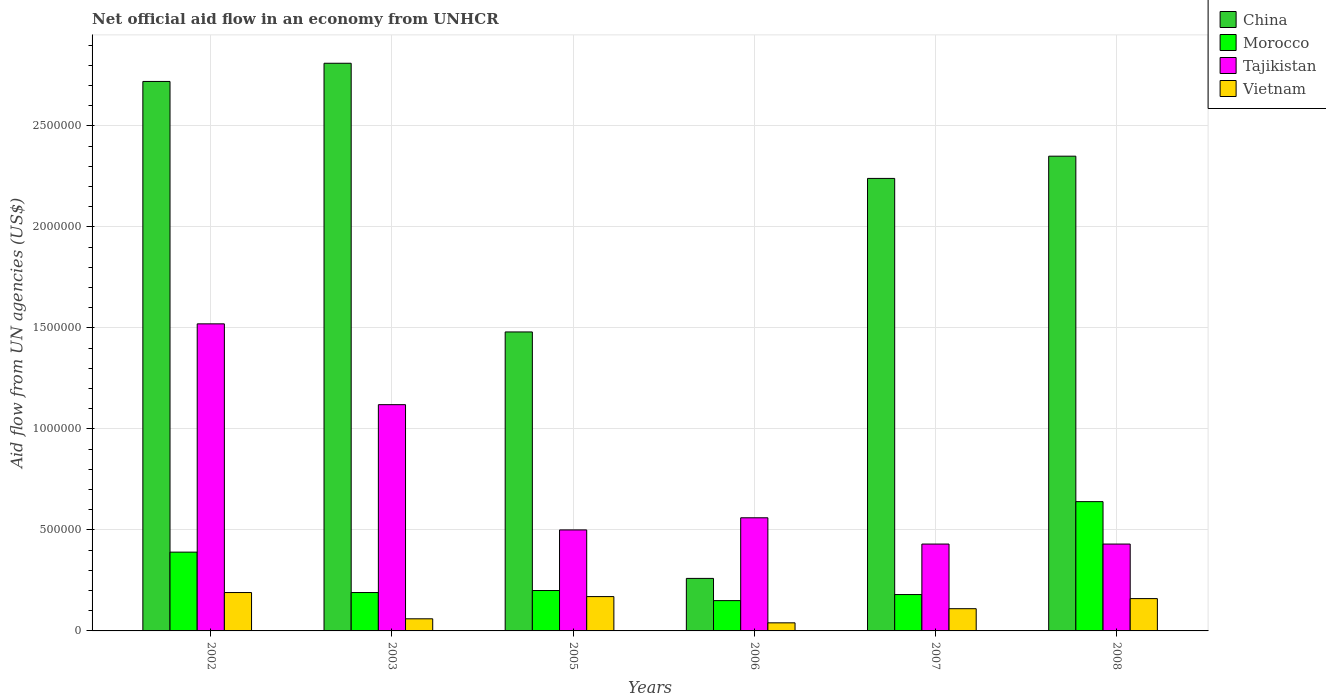How many different coloured bars are there?
Ensure brevity in your answer.  4. How many groups of bars are there?
Make the answer very short. 6. Are the number of bars per tick equal to the number of legend labels?
Ensure brevity in your answer.  Yes. Are the number of bars on each tick of the X-axis equal?
Your answer should be compact. Yes. In how many cases, is the number of bars for a given year not equal to the number of legend labels?
Offer a very short reply. 0. What is the net official aid flow in China in 2007?
Your response must be concise. 2.24e+06. Across all years, what is the maximum net official aid flow in Tajikistan?
Your response must be concise. 1.52e+06. Across all years, what is the minimum net official aid flow in Morocco?
Make the answer very short. 1.50e+05. In which year was the net official aid flow in Tajikistan maximum?
Offer a terse response. 2002. What is the total net official aid flow in China in the graph?
Provide a short and direct response. 1.19e+07. What is the difference between the net official aid flow in Tajikistan in 2003 and that in 2008?
Offer a very short reply. 6.90e+05. What is the difference between the net official aid flow in Tajikistan in 2003 and the net official aid flow in Morocco in 2005?
Give a very brief answer. 9.20e+05. What is the average net official aid flow in Vietnam per year?
Your answer should be very brief. 1.22e+05. In the year 2002, what is the difference between the net official aid flow in Morocco and net official aid flow in China?
Make the answer very short. -2.33e+06. What is the ratio of the net official aid flow in Morocco in 2005 to that in 2006?
Your answer should be very brief. 1.33. What is the difference between the highest and the second highest net official aid flow in Morocco?
Your answer should be very brief. 2.50e+05. What is the difference between the highest and the lowest net official aid flow in China?
Provide a succinct answer. 2.55e+06. In how many years, is the net official aid flow in Tajikistan greater than the average net official aid flow in Tajikistan taken over all years?
Ensure brevity in your answer.  2. What does the 4th bar from the left in 2007 represents?
Give a very brief answer. Vietnam. What does the 3rd bar from the right in 2003 represents?
Offer a terse response. Morocco. Is it the case that in every year, the sum of the net official aid flow in Vietnam and net official aid flow in Morocco is greater than the net official aid flow in China?
Offer a very short reply. No. How many years are there in the graph?
Your answer should be compact. 6. Are the values on the major ticks of Y-axis written in scientific E-notation?
Your answer should be very brief. No. Does the graph contain grids?
Provide a succinct answer. Yes. Where does the legend appear in the graph?
Offer a terse response. Top right. How are the legend labels stacked?
Offer a very short reply. Vertical. What is the title of the graph?
Offer a very short reply. Net official aid flow in an economy from UNHCR. What is the label or title of the X-axis?
Provide a succinct answer. Years. What is the label or title of the Y-axis?
Offer a terse response. Aid flow from UN agencies (US$). What is the Aid flow from UN agencies (US$) in China in 2002?
Offer a terse response. 2.72e+06. What is the Aid flow from UN agencies (US$) of Tajikistan in 2002?
Your response must be concise. 1.52e+06. What is the Aid flow from UN agencies (US$) in China in 2003?
Provide a short and direct response. 2.81e+06. What is the Aid flow from UN agencies (US$) of Morocco in 2003?
Make the answer very short. 1.90e+05. What is the Aid flow from UN agencies (US$) of Tajikistan in 2003?
Offer a very short reply. 1.12e+06. What is the Aid flow from UN agencies (US$) in China in 2005?
Your answer should be compact. 1.48e+06. What is the Aid flow from UN agencies (US$) in Morocco in 2005?
Offer a terse response. 2.00e+05. What is the Aid flow from UN agencies (US$) of Vietnam in 2005?
Offer a very short reply. 1.70e+05. What is the Aid flow from UN agencies (US$) in Tajikistan in 2006?
Offer a very short reply. 5.60e+05. What is the Aid flow from UN agencies (US$) of China in 2007?
Make the answer very short. 2.24e+06. What is the Aid flow from UN agencies (US$) of China in 2008?
Your answer should be compact. 2.35e+06. What is the Aid flow from UN agencies (US$) of Morocco in 2008?
Offer a very short reply. 6.40e+05. Across all years, what is the maximum Aid flow from UN agencies (US$) in China?
Give a very brief answer. 2.81e+06. Across all years, what is the maximum Aid flow from UN agencies (US$) in Morocco?
Keep it short and to the point. 6.40e+05. Across all years, what is the maximum Aid flow from UN agencies (US$) of Tajikistan?
Offer a terse response. 1.52e+06. Across all years, what is the minimum Aid flow from UN agencies (US$) in China?
Your answer should be very brief. 2.60e+05. Across all years, what is the minimum Aid flow from UN agencies (US$) in Morocco?
Offer a very short reply. 1.50e+05. Across all years, what is the minimum Aid flow from UN agencies (US$) of Vietnam?
Offer a terse response. 4.00e+04. What is the total Aid flow from UN agencies (US$) in China in the graph?
Your answer should be very brief. 1.19e+07. What is the total Aid flow from UN agencies (US$) in Morocco in the graph?
Provide a succinct answer. 1.75e+06. What is the total Aid flow from UN agencies (US$) of Tajikistan in the graph?
Keep it short and to the point. 4.56e+06. What is the total Aid flow from UN agencies (US$) in Vietnam in the graph?
Your answer should be very brief. 7.30e+05. What is the difference between the Aid flow from UN agencies (US$) in China in 2002 and that in 2003?
Provide a succinct answer. -9.00e+04. What is the difference between the Aid flow from UN agencies (US$) of Tajikistan in 2002 and that in 2003?
Provide a succinct answer. 4.00e+05. What is the difference between the Aid flow from UN agencies (US$) of China in 2002 and that in 2005?
Provide a succinct answer. 1.24e+06. What is the difference between the Aid flow from UN agencies (US$) of Morocco in 2002 and that in 2005?
Ensure brevity in your answer.  1.90e+05. What is the difference between the Aid flow from UN agencies (US$) in Tajikistan in 2002 and that in 2005?
Give a very brief answer. 1.02e+06. What is the difference between the Aid flow from UN agencies (US$) in Vietnam in 2002 and that in 2005?
Offer a very short reply. 2.00e+04. What is the difference between the Aid flow from UN agencies (US$) of China in 2002 and that in 2006?
Provide a short and direct response. 2.46e+06. What is the difference between the Aid flow from UN agencies (US$) of Tajikistan in 2002 and that in 2006?
Offer a very short reply. 9.60e+05. What is the difference between the Aid flow from UN agencies (US$) of China in 2002 and that in 2007?
Your answer should be very brief. 4.80e+05. What is the difference between the Aid flow from UN agencies (US$) of Tajikistan in 2002 and that in 2007?
Your answer should be very brief. 1.09e+06. What is the difference between the Aid flow from UN agencies (US$) in Vietnam in 2002 and that in 2007?
Offer a very short reply. 8.00e+04. What is the difference between the Aid flow from UN agencies (US$) of Morocco in 2002 and that in 2008?
Offer a terse response. -2.50e+05. What is the difference between the Aid flow from UN agencies (US$) in Tajikistan in 2002 and that in 2008?
Your response must be concise. 1.09e+06. What is the difference between the Aid flow from UN agencies (US$) of China in 2003 and that in 2005?
Keep it short and to the point. 1.33e+06. What is the difference between the Aid flow from UN agencies (US$) of Tajikistan in 2003 and that in 2005?
Offer a very short reply. 6.20e+05. What is the difference between the Aid flow from UN agencies (US$) of China in 2003 and that in 2006?
Offer a very short reply. 2.55e+06. What is the difference between the Aid flow from UN agencies (US$) of Tajikistan in 2003 and that in 2006?
Your response must be concise. 5.60e+05. What is the difference between the Aid flow from UN agencies (US$) in China in 2003 and that in 2007?
Ensure brevity in your answer.  5.70e+05. What is the difference between the Aid flow from UN agencies (US$) of Tajikistan in 2003 and that in 2007?
Provide a succinct answer. 6.90e+05. What is the difference between the Aid flow from UN agencies (US$) of Morocco in 2003 and that in 2008?
Your response must be concise. -4.50e+05. What is the difference between the Aid flow from UN agencies (US$) of Tajikistan in 2003 and that in 2008?
Offer a terse response. 6.90e+05. What is the difference between the Aid flow from UN agencies (US$) of China in 2005 and that in 2006?
Provide a succinct answer. 1.22e+06. What is the difference between the Aid flow from UN agencies (US$) of Morocco in 2005 and that in 2006?
Your answer should be compact. 5.00e+04. What is the difference between the Aid flow from UN agencies (US$) of China in 2005 and that in 2007?
Make the answer very short. -7.60e+05. What is the difference between the Aid flow from UN agencies (US$) in Morocco in 2005 and that in 2007?
Make the answer very short. 2.00e+04. What is the difference between the Aid flow from UN agencies (US$) of Vietnam in 2005 and that in 2007?
Your response must be concise. 6.00e+04. What is the difference between the Aid flow from UN agencies (US$) in China in 2005 and that in 2008?
Give a very brief answer. -8.70e+05. What is the difference between the Aid flow from UN agencies (US$) of Morocco in 2005 and that in 2008?
Give a very brief answer. -4.40e+05. What is the difference between the Aid flow from UN agencies (US$) in Tajikistan in 2005 and that in 2008?
Keep it short and to the point. 7.00e+04. What is the difference between the Aid flow from UN agencies (US$) in China in 2006 and that in 2007?
Give a very brief answer. -1.98e+06. What is the difference between the Aid flow from UN agencies (US$) in Morocco in 2006 and that in 2007?
Your response must be concise. -3.00e+04. What is the difference between the Aid flow from UN agencies (US$) in Tajikistan in 2006 and that in 2007?
Your answer should be compact. 1.30e+05. What is the difference between the Aid flow from UN agencies (US$) of China in 2006 and that in 2008?
Make the answer very short. -2.09e+06. What is the difference between the Aid flow from UN agencies (US$) in Morocco in 2006 and that in 2008?
Offer a very short reply. -4.90e+05. What is the difference between the Aid flow from UN agencies (US$) in Morocco in 2007 and that in 2008?
Offer a terse response. -4.60e+05. What is the difference between the Aid flow from UN agencies (US$) in Tajikistan in 2007 and that in 2008?
Keep it short and to the point. 0. What is the difference between the Aid flow from UN agencies (US$) in China in 2002 and the Aid flow from UN agencies (US$) in Morocco in 2003?
Give a very brief answer. 2.53e+06. What is the difference between the Aid flow from UN agencies (US$) of China in 2002 and the Aid flow from UN agencies (US$) of Tajikistan in 2003?
Give a very brief answer. 1.60e+06. What is the difference between the Aid flow from UN agencies (US$) in China in 2002 and the Aid flow from UN agencies (US$) in Vietnam in 2003?
Keep it short and to the point. 2.66e+06. What is the difference between the Aid flow from UN agencies (US$) of Morocco in 2002 and the Aid flow from UN agencies (US$) of Tajikistan in 2003?
Offer a terse response. -7.30e+05. What is the difference between the Aid flow from UN agencies (US$) in Morocco in 2002 and the Aid flow from UN agencies (US$) in Vietnam in 2003?
Provide a short and direct response. 3.30e+05. What is the difference between the Aid flow from UN agencies (US$) of Tajikistan in 2002 and the Aid flow from UN agencies (US$) of Vietnam in 2003?
Keep it short and to the point. 1.46e+06. What is the difference between the Aid flow from UN agencies (US$) in China in 2002 and the Aid flow from UN agencies (US$) in Morocco in 2005?
Make the answer very short. 2.52e+06. What is the difference between the Aid flow from UN agencies (US$) of China in 2002 and the Aid flow from UN agencies (US$) of Tajikistan in 2005?
Your answer should be compact. 2.22e+06. What is the difference between the Aid flow from UN agencies (US$) in China in 2002 and the Aid flow from UN agencies (US$) in Vietnam in 2005?
Provide a short and direct response. 2.55e+06. What is the difference between the Aid flow from UN agencies (US$) of Morocco in 2002 and the Aid flow from UN agencies (US$) of Tajikistan in 2005?
Your response must be concise. -1.10e+05. What is the difference between the Aid flow from UN agencies (US$) in Morocco in 2002 and the Aid flow from UN agencies (US$) in Vietnam in 2005?
Your answer should be compact. 2.20e+05. What is the difference between the Aid flow from UN agencies (US$) of Tajikistan in 2002 and the Aid flow from UN agencies (US$) of Vietnam in 2005?
Make the answer very short. 1.35e+06. What is the difference between the Aid flow from UN agencies (US$) of China in 2002 and the Aid flow from UN agencies (US$) of Morocco in 2006?
Provide a succinct answer. 2.57e+06. What is the difference between the Aid flow from UN agencies (US$) in China in 2002 and the Aid flow from UN agencies (US$) in Tajikistan in 2006?
Your response must be concise. 2.16e+06. What is the difference between the Aid flow from UN agencies (US$) of China in 2002 and the Aid flow from UN agencies (US$) of Vietnam in 2006?
Provide a succinct answer. 2.68e+06. What is the difference between the Aid flow from UN agencies (US$) in Morocco in 2002 and the Aid flow from UN agencies (US$) in Tajikistan in 2006?
Make the answer very short. -1.70e+05. What is the difference between the Aid flow from UN agencies (US$) in Tajikistan in 2002 and the Aid flow from UN agencies (US$) in Vietnam in 2006?
Provide a succinct answer. 1.48e+06. What is the difference between the Aid flow from UN agencies (US$) in China in 2002 and the Aid flow from UN agencies (US$) in Morocco in 2007?
Provide a succinct answer. 2.54e+06. What is the difference between the Aid flow from UN agencies (US$) of China in 2002 and the Aid flow from UN agencies (US$) of Tajikistan in 2007?
Your answer should be compact. 2.29e+06. What is the difference between the Aid flow from UN agencies (US$) of China in 2002 and the Aid flow from UN agencies (US$) of Vietnam in 2007?
Provide a succinct answer. 2.61e+06. What is the difference between the Aid flow from UN agencies (US$) in Morocco in 2002 and the Aid flow from UN agencies (US$) in Vietnam in 2007?
Make the answer very short. 2.80e+05. What is the difference between the Aid flow from UN agencies (US$) in Tajikistan in 2002 and the Aid flow from UN agencies (US$) in Vietnam in 2007?
Ensure brevity in your answer.  1.41e+06. What is the difference between the Aid flow from UN agencies (US$) in China in 2002 and the Aid flow from UN agencies (US$) in Morocco in 2008?
Your answer should be compact. 2.08e+06. What is the difference between the Aid flow from UN agencies (US$) in China in 2002 and the Aid flow from UN agencies (US$) in Tajikistan in 2008?
Provide a short and direct response. 2.29e+06. What is the difference between the Aid flow from UN agencies (US$) of China in 2002 and the Aid flow from UN agencies (US$) of Vietnam in 2008?
Give a very brief answer. 2.56e+06. What is the difference between the Aid flow from UN agencies (US$) of Morocco in 2002 and the Aid flow from UN agencies (US$) of Tajikistan in 2008?
Offer a terse response. -4.00e+04. What is the difference between the Aid flow from UN agencies (US$) of Morocco in 2002 and the Aid flow from UN agencies (US$) of Vietnam in 2008?
Your answer should be compact. 2.30e+05. What is the difference between the Aid flow from UN agencies (US$) in Tajikistan in 2002 and the Aid flow from UN agencies (US$) in Vietnam in 2008?
Your response must be concise. 1.36e+06. What is the difference between the Aid flow from UN agencies (US$) of China in 2003 and the Aid flow from UN agencies (US$) of Morocco in 2005?
Your response must be concise. 2.61e+06. What is the difference between the Aid flow from UN agencies (US$) in China in 2003 and the Aid flow from UN agencies (US$) in Tajikistan in 2005?
Make the answer very short. 2.31e+06. What is the difference between the Aid flow from UN agencies (US$) of China in 2003 and the Aid flow from UN agencies (US$) of Vietnam in 2005?
Your answer should be compact. 2.64e+06. What is the difference between the Aid flow from UN agencies (US$) in Morocco in 2003 and the Aid flow from UN agencies (US$) in Tajikistan in 2005?
Your answer should be compact. -3.10e+05. What is the difference between the Aid flow from UN agencies (US$) of Tajikistan in 2003 and the Aid flow from UN agencies (US$) of Vietnam in 2005?
Provide a succinct answer. 9.50e+05. What is the difference between the Aid flow from UN agencies (US$) in China in 2003 and the Aid flow from UN agencies (US$) in Morocco in 2006?
Keep it short and to the point. 2.66e+06. What is the difference between the Aid flow from UN agencies (US$) in China in 2003 and the Aid flow from UN agencies (US$) in Tajikistan in 2006?
Provide a succinct answer. 2.25e+06. What is the difference between the Aid flow from UN agencies (US$) in China in 2003 and the Aid flow from UN agencies (US$) in Vietnam in 2006?
Offer a very short reply. 2.77e+06. What is the difference between the Aid flow from UN agencies (US$) in Morocco in 2003 and the Aid flow from UN agencies (US$) in Tajikistan in 2006?
Keep it short and to the point. -3.70e+05. What is the difference between the Aid flow from UN agencies (US$) of Tajikistan in 2003 and the Aid flow from UN agencies (US$) of Vietnam in 2006?
Ensure brevity in your answer.  1.08e+06. What is the difference between the Aid flow from UN agencies (US$) of China in 2003 and the Aid flow from UN agencies (US$) of Morocco in 2007?
Offer a very short reply. 2.63e+06. What is the difference between the Aid flow from UN agencies (US$) of China in 2003 and the Aid flow from UN agencies (US$) of Tajikistan in 2007?
Ensure brevity in your answer.  2.38e+06. What is the difference between the Aid flow from UN agencies (US$) in China in 2003 and the Aid flow from UN agencies (US$) in Vietnam in 2007?
Give a very brief answer. 2.70e+06. What is the difference between the Aid flow from UN agencies (US$) of Morocco in 2003 and the Aid flow from UN agencies (US$) of Tajikistan in 2007?
Your answer should be compact. -2.40e+05. What is the difference between the Aid flow from UN agencies (US$) in Tajikistan in 2003 and the Aid flow from UN agencies (US$) in Vietnam in 2007?
Your answer should be compact. 1.01e+06. What is the difference between the Aid flow from UN agencies (US$) in China in 2003 and the Aid flow from UN agencies (US$) in Morocco in 2008?
Give a very brief answer. 2.17e+06. What is the difference between the Aid flow from UN agencies (US$) of China in 2003 and the Aid flow from UN agencies (US$) of Tajikistan in 2008?
Provide a short and direct response. 2.38e+06. What is the difference between the Aid flow from UN agencies (US$) of China in 2003 and the Aid flow from UN agencies (US$) of Vietnam in 2008?
Your answer should be compact. 2.65e+06. What is the difference between the Aid flow from UN agencies (US$) of Morocco in 2003 and the Aid flow from UN agencies (US$) of Tajikistan in 2008?
Your answer should be compact. -2.40e+05. What is the difference between the Aid flow from UN agencies (US$) in Morocco in 2003 and the Aid flow from UN agencies (US$) in Vietnam in 2008?
Keep it short and to the point. 3.00e+04. What is the difference between the Aid flow from UN agencies (US$) of Tajikistan in 2003 and the Aid flow from UN agencies (US$) of Vietnam in 2008?
Provide a succinct answer. 9.60e+05. What is the difference between the Aid flow from UN agencies (US$) in China in 2005 and the Aid flow from UN agencies (US$) in Morocco in 2006?
Provide a succinct answer. 1.33e+06. What is the difference between the Aid flow from UN agencies (US$) of China in 2005 and the Aid flow from UN agencies (US$) of Tajikistan in 2006?
Provide a succinct answer. 9.20e+05. What is the difference between the Aid flow from UN agencies (US$) in China in 2005 and the Aid flow from UN agencies (US$) in Vietnam in 2006?
Ensure brevity in your answer.  1.44e+06. What is the difference between the Aid flow from UN agencies (US$) in Morocco in 2005 and the Aid flow from UN agencies (US$) in Tajikistan in 2006?
Give a very brief answer. -3.60e+05. What is the difference between the Aid flow from UN agencies (US$) in Tajikistan in 2005 and the Aid flow from UN agencies (US$) in Vietnam in 2006?
Give a very brief answer. 4.60e+05. What is the difference between the Aid flow from UN agencies (US$) in China in 2005 and the Aid flow from UN agencies (US$) in Morocco in 2007?
Give a very brief answer. 1.30e+06. What is the difference between the Aid flow from UN agencies (US$) of China in 2005 and the Aid flow from UN agencies (US$) of Tajikistan in 2007?
Your answer should be compact. 1.05e+06. What is the difference between the Aid flow from UN agencies (US$) in China in 2005 and the Aid flow from UN agencies (US$) in Vietnam in 2007?
Offer a very short reply. 1.37e+06. What is the difference between the Aid flow from UN agencies (US$) of Morocco in 2005 and the Aid flow from UN agencies (US$) of Vietnam in 2007?
Provide a short and direct response. 9.00e+04. What is the difference between the Aid flow from UN agencies (US$) of Tajikistan in 2005 and the Aid flow from UN agencies (US$) of Vietnam in 2007?
Provide a short and direct response. 3.90e+05. What is the difference between the Aid flow from UN agencies (US$) of China in 2005 and the Aid flow from UN agencies (US$) of Morocco in 2008?
Keep it short and to the point. 8.40e+05. What is the difference between the Aid flow from UN agencies (US$) of China in 2005 and the Aid flow from UN agencies (US$) of Tajikistan in 2008?
Your answer should be very brief. 1.05e+06. What is the difference between the Aid flow from UN agencies (US$) of China in 2005 and the Aid flow from UN agencies (US$) of Vietnam in 2008?
Offer a terse response. 1.32e+06. What is the difference between the Aid flow from UN agencies (US$) of Morocco in 2005 and the Aid flow from UN agencies (US$) of Tajikistan in 2008?
Make the answer very short. -2.30e+05. What is the difference between the Aid flow from UN agencies (US$) of Morocco in 2005 and the Aid flow from UN agencies (US$) of Vietnam in 2008?
Make the answer very short. 4.00e+04. What is the difference between the Aid flow from UN agencies (US$) in Tajikistan in 2005 and the Aid flow from UN agencies (US$) in Vietnam in 2008?
Offer a terse response. 3.40e+05. What is the difference between the Aid flow from UN agencies (US$) of China in 2006 and the Aid flow from UN agencies (US$) of Morocco in 2007?
Offer a very short reply. 8.00e+04. What is the difference between the Aid flow from UN agencies (US$) in China in 2006 and the Aid flow from UN agencies (US$) in Tajikistan in 2007?
Offer a very short reply. -1.70e+05. What is the difference between the Aid flow from UN agencies (US$) in China in 2006 and the Aid flow from UN agencies (US$) in Vietnam in 2007?
Offer a very short reply. 1.50e+05. What is the difference between the Aid flow from UN agencies (US$) in Morocco in 2006 and the Aid flow from UN agencies (US$) in Tajikistan in 2007?
Your answer should be very brief. -2.80e+05. What is the difference between the Aid flow from UN agencies (US$) of Morocco in 2006 and the Aid flow from UN agencies (US$) of Vietnam in 2007?
Your answer should be compact. 4.00e+04. What is the difference between the Aid flow from UN agencies (US$) of Tajikistan in 2006 and the Aid flow from UN agencies (US$) of Vietnam in 2007?
Your response must be concise. 4.50e+05. What is the difference between the Aid flow from UN agencies (US$) of China in 2006 and the Aid flow from UN agencies (US$) of Morocco in 2008?
Your answer should be very brief. -3.80e+05. What is the difference between the Aid flow from UN agencies (US$) in Morocco in 2006 and the Aid flow from UN agencies (US$) in Tajikistan in 2008?
Offer a terse response. -2.80e+05. What is the difference between the Aid flow from UN agencies (US$) of Tajikistan in 2006 and the Aid flow from UN agencies (US$) of Vietnam in 2008?
Provide a succinct answer. 4.00e+05. What is the difference between the Aid flow from UN agencies (US$) in China in 2007 and the Aid flow from UN agencies (US$) in Morocco in 2008?
Keep it short and to the point. 1.60e+06. What is the difference between the Aid flow from UN agencies (US$) of China in 2007 and the Aid flow from UN agencies (US$) of Tajikistan in 2008?
Provide a short and direct response. 1.81e+06. What is the difference between the Aid flow from UN agencies (US$) in China in 2007 and the Aid flow from UN agencies (US$) in Vietnam in 2008?
Offer a very short reply. 2.08e+06. What is the difference between the Aid flow from UN agencies (US$) of Morocco in 2007 and the Aid flow from UN agencies (US$) of Tajikistan in 2008?
Provide a short and direct response. -2.50e+05. What is the average Aid flow from UN agencies (US$) in China per year?
Provide a short and direct response. 1.98e+06. What is the average Aid flow from UN agencies (US$) in Morocco per year?
Give a very brief answer. 2.92e+05. What is the average Aid flow from UN agencies (US$) in Tajikistan per year?
Provide a succinct answer. 7.60e+05. What is the average Aid flow from UN agencies (US$) in Vietnam per year?
Your answer should be compact. 1.22e+05. In the year 2002, what is the difference between the Aid flow from UN agencies (US$) of China and Aid flow from UN agencies (US$) of Morocco?
Make the answer very short. 2.33e+06. In the year 2002, what is the difference between the Aid flow from UN agencies (US$) in China and Aid flow from UN agencies (US$) in Tajikistan?
Make the answer very short. 1.20e+06. In the year 2002, what is the difference between the Aid flow from UN agencies (US$) of China and Aid flow from UN agencies (US$) of Vietnam?
Your answer should be very brief. 2.53e+06. In the year 2002, what is the difference between the Aid flow from UN agencies (US$) in Morocco and Aid flow from UN agencies (US$) in Tajikistan?
Your answer should be compact. -1.13e+06. In the year 2002, what is the difference between the Aid flow from UN agencies (US$) of Tajikistan and Aid flow from UN agencies (US$) of Vietnam?
Provide a succinct answer. 1.33e+06. In the year 2003, what is the difference between the Aid flow from UN agencies (US$) in China and Aid flow from UN agencies (US$) in Morocco?
Keep it short and to the point. 2.62e+06. In the year 2003, what is the difference between the Aid flow from UN agencies (US$) in China and Aid flow from UN agencies (US$) in Tajikistan?
Your answer should be very brief. 1.69e+06. In the year 2003, what is the difference between the Aid flow from UN agencies (US$) of China and Aid flow from UN agencies (US$) of Vietnam?
Make the answer very short. 2.75e+06. In the year 2003, what is the difference between the Aid flow from UN agencies (US$) in Morocco and Aid flow from UN agencies (US$) in Tajikistan?
Your answer should be compact. -9.30e+05. In the year 2003, what is the difference between the Aid flow from UN agencies (US$) of Morocco and Aid flow from UN agencies (US$) of Vietnam?
Make the answer very short. 1.30e+05. In the year 2003, what is the difference between the Aid flow from UN agencies (US$) of Tajikistan and Aid flow from UN agencies (US$) of Vietnam?
Your response must be concise. 1.06e+06. In the year 2005, what is the difference between the Aid flow from UN agencies (US$) in China and Aid flow from UN agencies (US$) in Morocco?
Your answer should be very brief. 1.28e+06. In the year 2005, what is the difference between the Aid flow from UN agencies (US$) in China and Aid flow from UN agencies (US$) in Tajikistan?
Your response must be concise. 9.80e+05. In the year 2005, what is the difference between the Aid flow from UN agencies (US$) in China and Aid flow from UN agencies (US$) in Vietnam?
Provide a short and direct response. 1.31e+06. In the year 2005, what is the difference between the Aid flow from UN agencies (US$) of Morocco and Aid flow from UN agencies (US$) of Tajikistan?
Your response must be concise. -3.00e+05. In the year 2006, what is the difference between the Aid flow from UN agencies (US$) in China and Aid flow from UN agencies (US$) in Morocco?
Provide a succinct answer. 1.10e+05. In the year 2006, what is the difference between the Aid flow from UN agencies (US$) of China and Aid flow from UN agencies (US$) of Tajikistan?
Your answer should be compact. -3.00e+05. In the year 2006, what is the difference between the Aid flow from UN agencies (US$) of China and Aid flow from UN agencies (US$) of Vietnam?
Give a very brief answer. 2.20e+05. In the year 2006, what is the difference between the Aid flow from UN agencies (US$) in Morocco and Aid flow from UN agencies (US$) in Tajikistan?
Give a very brief answer. -4.10e+05. In the year 2006, what is the difference between the Aid flow from UN agencies (US$) in Tajikistan and Aid flow from UN agencies (US$) in Vietnam?
Provide a short and direct response. 5.20e+05. In the year 2007, what is the difference between the Aid flow from UN agencies (US$) in China and Aid flow from UN agencies (US$) in Morocco?
Make the answer very short. 2.06e+06. In the year 2007, what is the difference between the Aid flow from UN agencies (US$) in China and Aid flow from UN agencies (US$) in Tajikistan?
Offer a terse response. 1.81e+06. In the year 2007, what is the difference between the Aid flow from UN agencies (US$) of China and Aid flow from UN agencies (US$) of Vietnam?
Your answer should be very brief. 2.13e+06. In the year 2007, what is the difference between the Aid flow from UN agencies (US$) of Tajikistan and Aid flow from UN agencies (US$) of Vietnam?
Your answer should be very brief. 3.20e+05. In the year 2008, what is the difference between the Aid flow from UN agencies (US$) of China and Aid flow from UN agencies (US$) of Morocco?
Provide a short and direct response. 1.71e+06. In the year 2008, what is the difference between the Aid flow from UN agencies (US$) of China and Aid flow from UN agencies (US$) of Tajikistan?
Keep it short and to the point. 1.92e+06. In the year 2008, what is the difference between the Aid flow from UN agencies (US$) in China and Aid flow from UN agencies (US$) in Vietnam?
Offer a very short reply. 2.19e+06. In the year 2008, what is the difference between the Aid flow from UN agencies (US$) of Tajikistan and Aid flow from UN agencies (US$) of Vietnam?
Offer a terse response. 2.70e+05. What is the ratio of the Aid flow from UN agencies (US$) in Morocco in 2002 to that in 2003?
Offer a terse response. 2.05. What is the ratio of the Aid flow from UN agencies (US$) of Tajikistan in 2002 to that in 2003?
Make the answer very short. 1.36. What is the ratio of the Aid flow from UN agencies (US$) of Vietnam in 2002 to that in 2003?
Provide a short and direct response. 3.17. What is the ratio of the Aid flow from UN agencies (US$) in China in 2002 to that in 2005?
Offer a terse response. 1.84. What is the ratio of the Aid flow from UN agencies (US$) in Morocco in 2002 to that in 2005?
Offer a very short reply. 1.95. What is the ratio of the Aid flow from UN agencies (US$) in Tajikistan in 2002 to that in 2005?
Keep it short and to the point. 3.04. What is the ratio of the Aid flow from UN agencies (US$) in Vietnam in 2002 to that in 2005?
Your response must be concise. 1.12. What is the ratio of the Aid flow from UN agencies (US$) in China in 2002 to that in 2006?
Your response must be concise. 10.46. What is the ratio of the Aid flow from UN agencies (US$) in Tajikistan in 2002 to that in 2006?
Provide a short and direct response. 2.71. What is the ratio of the Aid flow from UN agencies (US$) in Vietnam in 2002 to that in 2006?
Keep it short and to the point. 4.75. What is the ratio of the Aid flow from UN agencies (US$) in China in 2002 to that in 2007?
Make the answer very short. 1.21. What is the ratio of the Aid flow from UN agencies (US$) of Morocco in 2002 to that in 2007?
Give a very brief answer. 2.17. What is the ratio of the Aid flow from UN agencies (US$) in Tajikistan in 2002 to that in 2007?
Your answer should be compact. 3.53. What is the ratio of the Aid flow from UN agencies (US$) in Vietnam in 2002 to that in 2007?
Your answer should be very brief. 1.73. What is the ratio of the Aid flow from UN agencies (US$) of China in 2002 to that in 2008?
Provide a short and direct response. 1.16. What is the ratio of the Aid flow from UN agencies (US$) of Morocco in 2002 to that in 2008?
Your response must be concise. 0.61. What is the ratio of the Aid flow from UN agencies (US$) of Tajikistan in 2002 to that in 2008?
Keep it short and to the point. 3.53. What is the ratio of the Aid flow from UN agencies (US$) of Vietnam in 2002 to that in 2008?
Provide a short and direct response. 1.19. What is the ratio of the Aid flow from UN agencies (US$) in China in 2003 to that in 2005?
Make the answer very short. 1.9. What is the ratio of the Aid flow from UN agencies (US$) in Tajikistan in 2003 to that in 2005?
Your answer should be very brief. 2.24. What is the ratio of the Aid flow from UN agencies (US$) in Vietnam in 2003 to that in 2005?
Your answer should be compact. 0.35. What is the ratio of the Aid flow from UN agencies (US$) in China in 2003 to that in 2006?
Your answer should be compact. 10.81. What is the ratio of the Aid flow from UN agencies (US$) of Morocco in 2003 to that in 2006?
Offer a terse response. 1.27. What is the ratio of the Aid flow from UN agencies (US$) in Tajikistan in 2003 to that in 2006?
Your response must be concise. 2. What is the ratio of the Aid flow from UN agencies (US$) of China in 2003 to that in 2007?
Give a very brief answer. 1.25. What is the ratio of the Aid flow from UN agencies (US$) of Morocco in 2003 to that in 2007?
Keep it short and to the point. 1.06. What is the ratio of the Aid flow from UN agencies (US$) of Tajikistan in 2003 to that in 2007?
Keep it short and to the point. 2.6. What is the ratio of the Aid flow from UN agencies (US$) of Vietnam in 2003 to that in 2007?
Provide a short and direct response. 0.55. What is the ratio of the Aid flow from UN agencies (US$) of China in 2003 to that in 2008?
Your response must be concise. 1.2. What is the ratio of the Aid flow from UN agencies (US$) of Morocco in 2003 to that in 2008?
Your answer should be compact. 0.3. What is the ratio of the Aid flow from UN agencies (US$) of Tajikistan in 2003 to that in 2008?
Your response must be concise. 2.6. What is the ratio of the Aid flow from UN agencies (US$) of Vietnam in 2003 to that in 2008?
Give a very brief answer. 0.38. What is the ratio of the Aid flow from UN agencies (US$) of China in 2005 to that in 2006?
Provide a succinct answer. 5.69. What is the ratio of the Aid flow from UN agencies (US$) in Morocco in 2005 to that in 2006?
Keep it short and to the point. 1.33. What is the ratio of the Aid flow from UN agencies (US$) of Tajikistan in 2005 to that in 2006?
Provide a short and direct response. 0.89. What is the ratio of the Aid flow from UN agencies (US$) in Vietnam in 2005 to that in 2006?
Your answer should be very brief. 4.25. What is the ratio of the Aid flow from UN agencies (US$) of China in 2005 to that in 2007?
Your response must be concise. 0.66. What is the ratio of the Aid flow from UN agencies (US$) in Tajikistan in 2005 to that in 2007?
Offer a very short reply. 1.16. What is the ratio of the Aid flow from UN agencies (US$) in Vietnam in 2005 to that in 2007?
Offer a very short reply. 1.55. What is the ratio of the Aid flow from UN agencies (US$) in China in 2005 to that in 2008?
Provide a succinct answer. 0.63. What is the ratio of the Aid flow from UN agencies (US$) in Morocco in 2005 to that in 2008?
Provide a short and direct response. 0.31. What is the ratio of the Aid flow from UN agencies (US$) of Tajikistan in 2005 to that in 2008?
Give a very brief answer. 1.16. What is the ratio of the Aid flow from UN agencies (US$) of Vietnam in 2005 to that in 2008?
Give a very brief answer. 1.06. What is the ratio of the Aid flow from UN agencies (US$) of China in 2006 to that in 2007?
Offer a very short reply. 0.12. What is the ratio of the Aid flow from UN agencies (US$) of Tajikistan in 2006 to that in 2007?
Your response must be concise. 1.3. What is the ratio of the Aid flow from UN agencies (US$) in Vietnam in 2006 to that in 2007?
Your answer should be compact. 0.36. What is the ratio of the Aid flow from UN agencies (US$) in China in 2006 to that in 2008?
Make the answer very short. 0.11. What is the ratio of the Aid flow from UN agencies (US$) in Morocco in 2006 to that in 2008?
Offer a terse response. 0.23. What is the ratio of the Aid flow from UN agencies (US$) in Tajikistan in 2006 to that in 2008?
Make the answer very short. 1.3. What is the ratio of the Aid flow from UN agencies (US$) in China in 2007 to that in 2008?
Keep it short and to the point. 0.95. What is the ratio of the Aid flow from UN agencies (US$) in Morocco in 2007 to that in 2008?
Provide a short and direct response. 0.28. What is the ratio of the Aid flow from UN agencies (US$) in Tajikistan in 2007 to that in 2008?
Your answer should be very brief. 1. What is the ratio of the Aid flow from UN agencies (US$) of Vietnam in 2007 to that in 2008?
Make the answer very short. 0.69. What is the difference between the highest and the second highest Aid flow from UN agencies (US$) of Vietnam?
Your response must be concise. 2.00e+04. What is the difference between the highest and the lowest Aid flow from UN agencies (US$) of China?
Your response must be concise. 2.55e+06. What is the difference between the highest and the lowest Aid flow from UN agencies (US$) of Tajikistan?
Provide a succinct answer. 1.09e+06. 